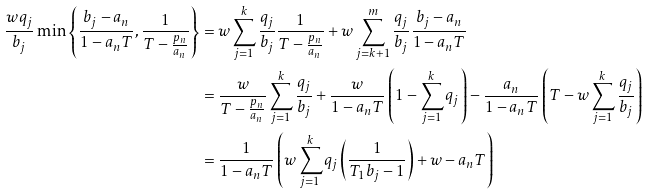Convert formula to latex. <formula><loc_0><loc_0><loc_500><loc_500>\frac { w q _ { j } } { b _ { j } } \min \left \{ \frac { b _ { j } - a _ { n } } { 1 - a _ { n } T } , \frac { 1 } { T - \frac { p _ { n } } { a _ { n } } } \right \} & = w \sum _ { j = 1 } ^ { k } \frac { q _ { j } } { b _ { j } } \frac { 1 } { T - \frac { p _ { n } } { a _ { n } } } + w \sum _ { j = k + 1 } ^ { m } \frac { q _ { j } } { b _ { j } } \frac { b _ { j } - a _ { n } } { 1 - a _ { n } T } \\ & = \frac { w } { T - \frac { p _ { n } } { a _ { n } } } \sum _ { j = 1 } ^ { k } \frac { q _ { j } } { b _ { j } } + \frac { w } { 1 - a _ { n } T } \left ( 1 - \sum _ { j = 1 } ^ { k } q _ { j } \right ) - \frac { a _ { n } } { 1 - a _ { n } T } \left ( T - w \sum _ { j = 1 } ^ { k } \frac { q _ { j } } { b _ { j } } \right ) \\ & = \frac { 1 } { 1 - a _ { n } T } \left ( w \sum _ { j = 1 } ^ { k } q _ { j } \left ( \frac { 1 } { T _ { 1 } b _ { j } - 1 } \right ) + w - a _ { n } T \right )</formula> 